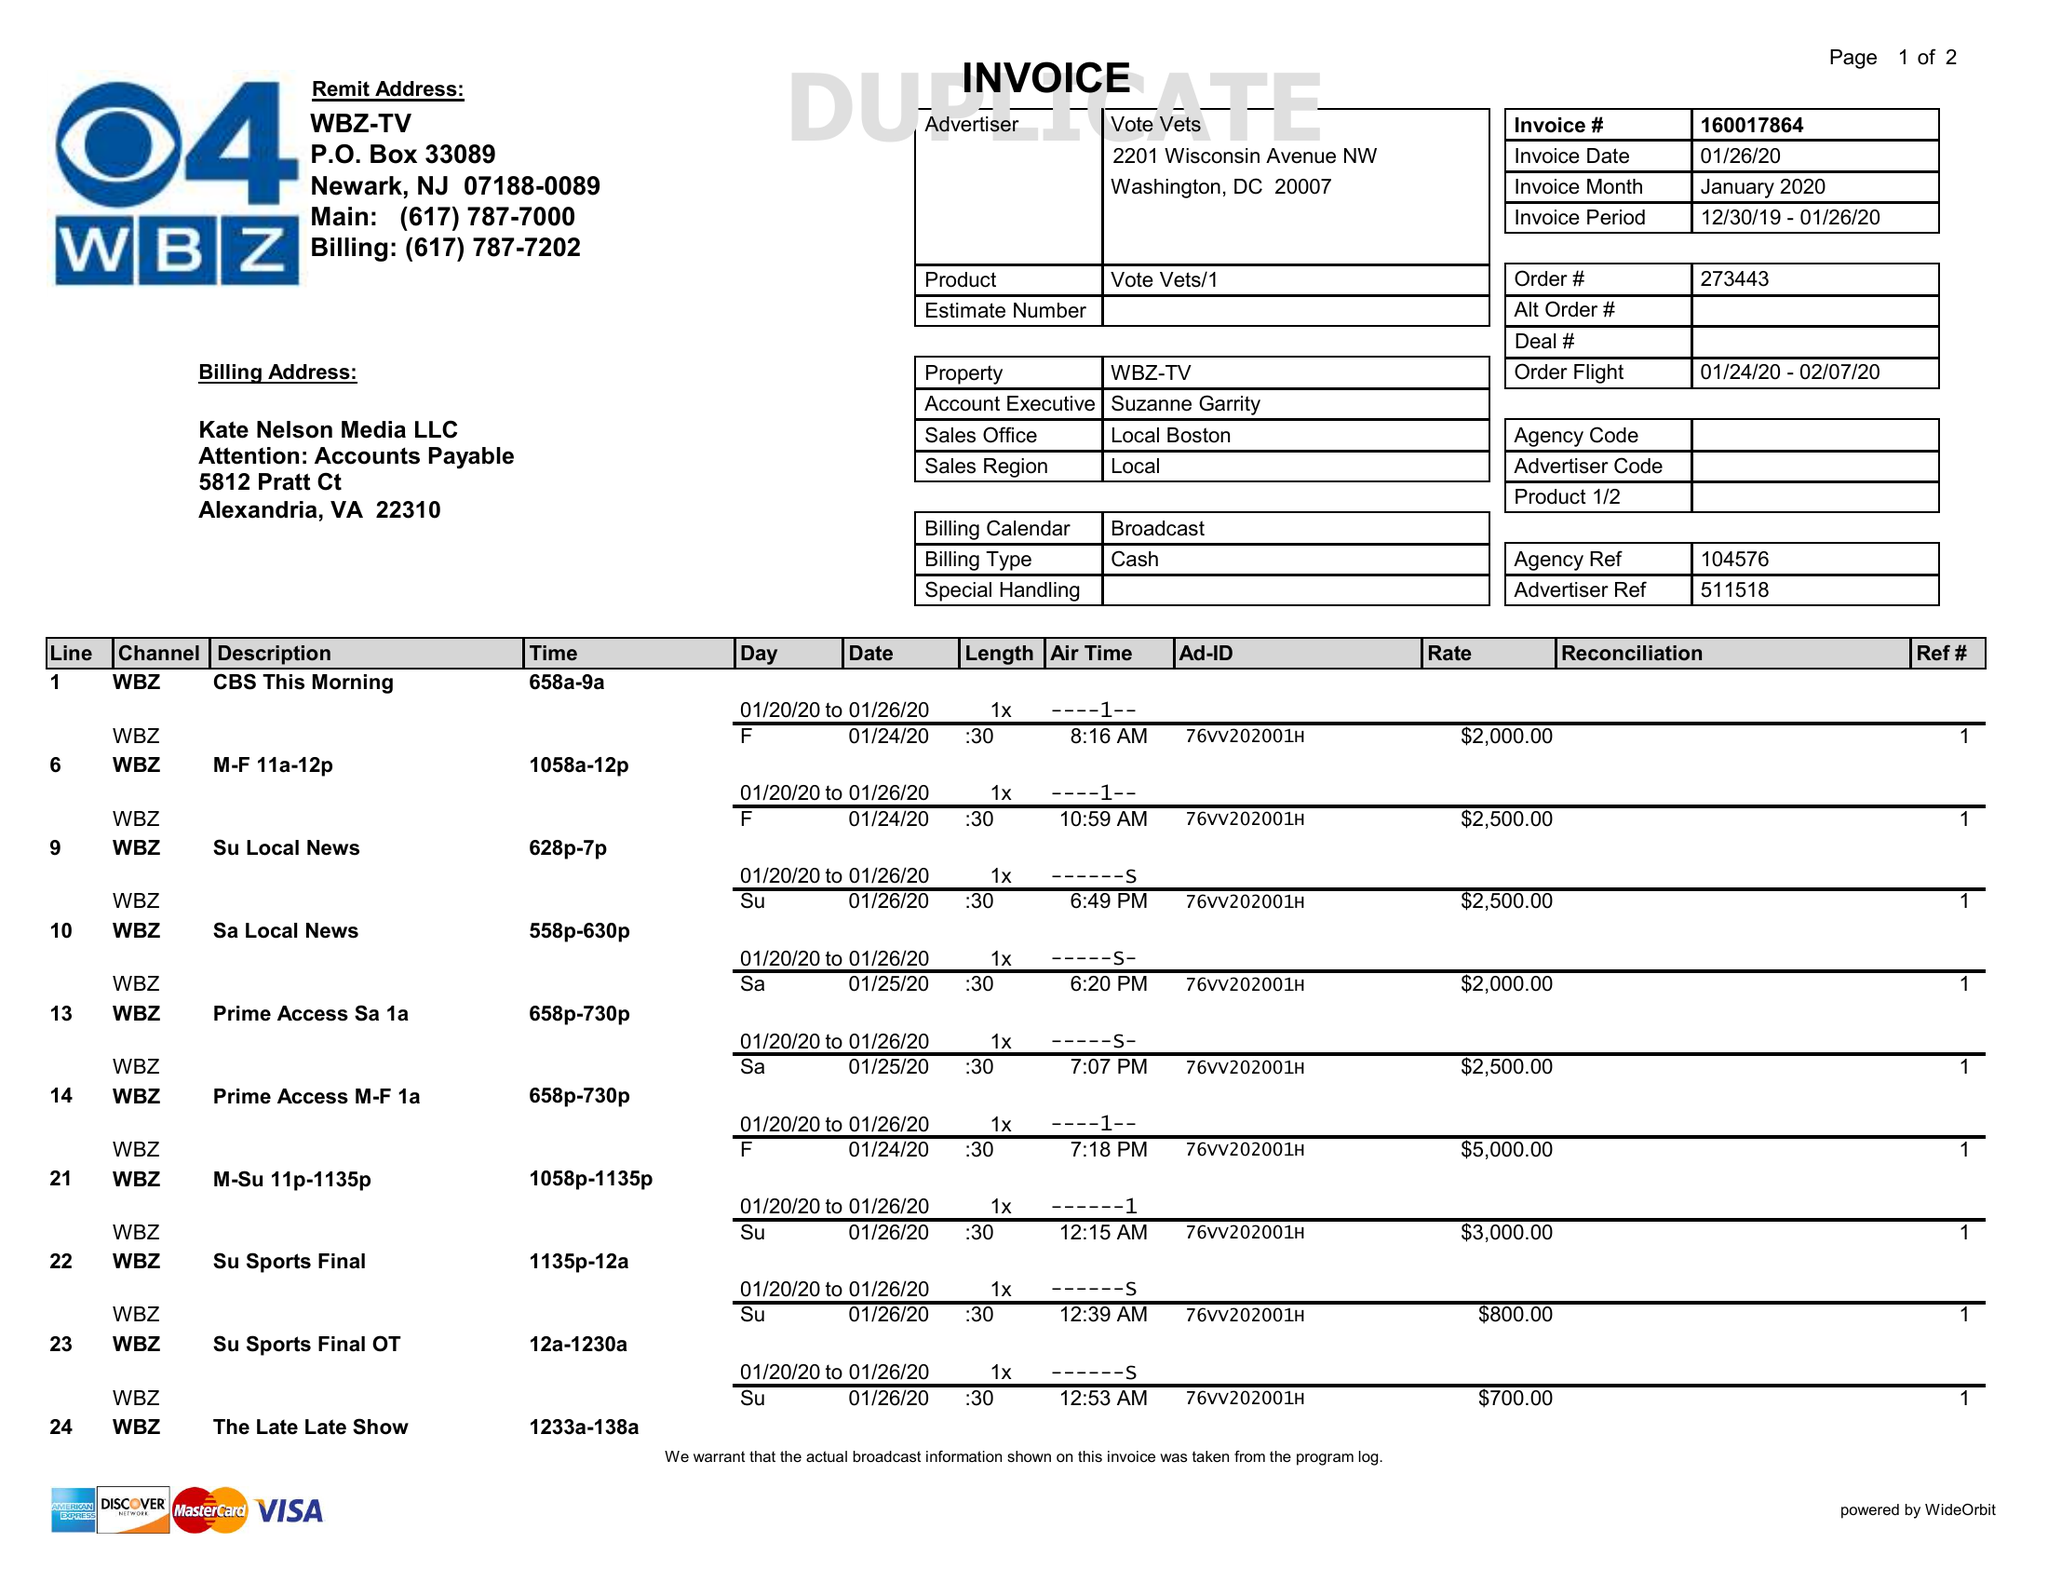What is the value for the contract_num?
Answer the question using a single word or phrase. 160017864 